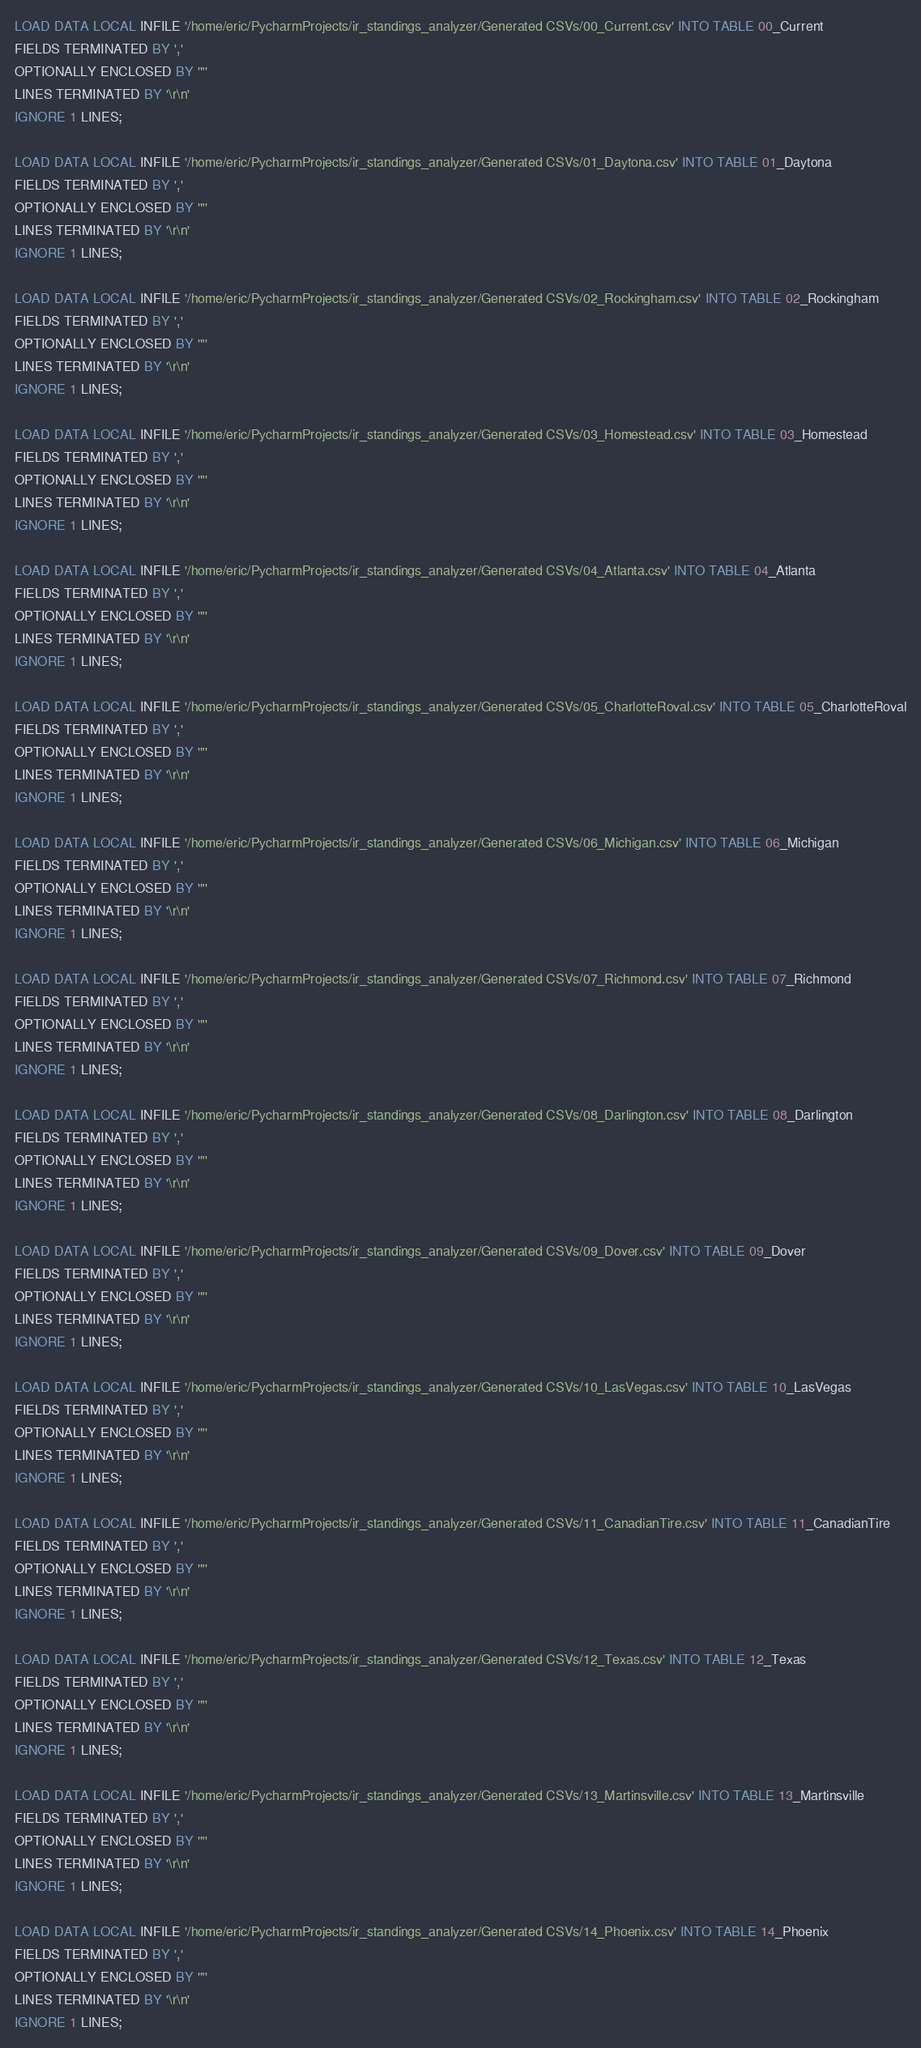Convert code to text. <code><loc_0><loc_0><loc_500><loc_500><_SQL_>LOAD DATA LOCAL INFILE '/home/eric/PycharmProjects/ir_standings_analyzer/Generated CSVs/00_Current.csv' INTO TABLE 00_Current
FIELDS TERMINATED BY ','
OPTIONALLY ENCLOSED BY '"'
LINES TERMINATED BY '\r\n'
IGNORE 1 LINES;

LOAD DATA LOCAL INFILE '/home/eric/PycharmProjects/ir_standings_analyzer/Generated CSVs/01_Daytona.csv' INTO TABLE 01_Daytona
FIELDS TERMINATED BY ','
OPTIONALLY ENCLOSED BY '"'
LINES TERMINATED BY '\r\n'
IGNORE 1 LINES;

LOAD DATA LOCAL INFILE '/home/eric/PycharmProjects/ir_standings_analyzer/Generated CSVs/02_Rockingham.csv' INTO TABLE 02_Rockingham
FIELDS TERMINATED BY ','
OPTIONALLY ENCLOSED BY '"'
LINES TERMINATED BY '\r\n'
IGNORE 1 LINES;

LOAD DATA LOCAL INFILE '/home/eric/PycharmProjects/ir_standings_analyzer/Generated CSVs/03_Homestead.csv' INTO TABLE 03_Homestead
FIELDS TERMINATED BY ','
OPTIONALLY ENCLOSED BY '"'
LINES TERMINATED BY '\r\n'
IGNORE 1 LINES;

LOAD DATA LOCAL INFILE '/home/eric/PycharmProjects/ir_standings_analyzer/Generated CSVs/04_Atlanta.csv' INTO TABLE 04_Atlanta
FIELDS TERMINATED BY ','
OPTIONALLY ENCLOSED BY '"'
LINES TERMINATED BY '\r\n'
IGNORE 1 LINES;

LOAD DATA LOCAL INFILE '/home/eric/PycharmProjects/ir_standings_analyzer/Generated CSVs/05_CharlotteRoval.csv' INTO TABLE 05_CharlotteRoval
FIELDS TERMINATED BY ','
OPTIONALLY ENCLOSED BY '"'
LINES TERMINATED BY '\r\n'
IGNORE 1 LINES;

LOAD DATA LOCAL INFILE '/home/eric/PycharmProjects/ir_standings_analyzer/Generated CSVs/06_Michigan.csv' INTO TABLE 06_Michigan
FIELDS TERMINATED BY ','
OPTIONALLY ENCLOSED BY '"'
LINES TERMINATED BY '\r\n'
IGNORE 1 LINES;

LOAD DATA LOCAL INFILE '/home/eric/PycharmProjects/ir_standings_analyzer/Generated CSVs/07_Richmond.csv' INTO TABLE 07_Richmond
FIELDS TERMINATED BY ','
OPTIONALLY ENCLOSED BY '"'
LINES TERMINATED BY '\r\n'
IGNORE 1 LINES;

LOAD DATA LOCAL INFILE '/home/eric/PycharmProjects/ir_standings_analyzer/Generated CSVs/08_Darlington.csv' INTO TABLE 08_Darlington
FIELDS TERMINATED BY ','
OPTIONALLY ENCLOSED BY '"'
LINES TERMINATED BY '\r\n'
IGNORE 1 LINES;

LOAD DATA LOCAL INFILE '/home/eric/PycharmProjects/ir_standings_analyzer/Generated CSVs/09_Dover.csv' INTO TABLE 09_Dover
FIELDS TERMINATED BY ','
OPTIONALLY ENCLOSED BY '"'
LINES TERMINATED BY '\r\n'
IGNORE 1 LINES;

LOAD DATA LOCAL INFILE '/home/eric/PycharmProjects/ir_standings_analyzer/Generated CSVs/10_LasVegas.csv' INTO TABLE 10_LasVegas
FIELDS TERMINATED BY ','
OPTIONALLY ENCLOSED BY '"'
LINES TERMINATED BY '\r\n'
IGNORE 1 LINES;

LOAD DATA LOCAL INFILE '/home/eric/PycharmProjects/ir_standings_analyzer/Generated CSVs/11_CanadianTire.csv' INTO TABLE 11_CanadianTire
FIELDS TERMINATED BY ','
OPTIONALLY ENCLOSED BY '"'
LINES TERMINATED BY '\r\n'
IGNORE 1 LINES;

LOAD DATA LOCAL INFILE '/home/eric/PycharmProjects/ir_standings_analyzer/Generated CSVs/12_Texas.csv' INTO TABLE 12_Texas
FIELDS TERMINATED BY ','
OPTIONALLY ENCLOSED BY '"'
LINES TERMINATED BY '\r\n'
IGNORE 1 LINES;

LOAD DATA LOCAL INFILE '/home/eric/PycharmProjects/ir_standings_analyzer/Generated CSVs/13_Martinsville.csv' INTO TABLE 13_Martinsville
FIELDS TERMINATED BY ','
OPTIONALLY ENCLOSED BY '"'
LINES TERMINATED BY '\r\n'
IGNORE 1 LINES;

LOAD DATA LOCAL INFILE '/home/eric/PycharmProjects/ir_standings_analyzer/Generated CSVs/14_Phoenix.csv' INTO TABLE 14_Phoenix
FIELDS TERMINATED BY ','
OPTIONALLY ENCLOSED BY '"'
LINES TERMINATED BY '\r\n'
IGNORE 1 LINES;</code> 